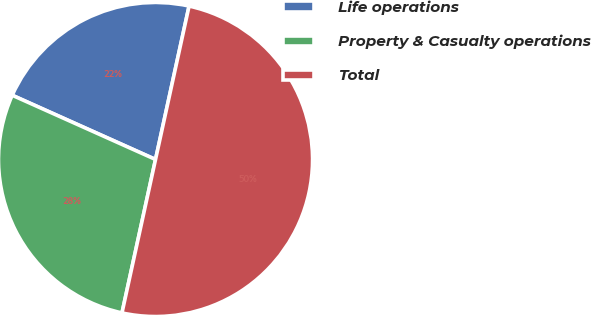<chart> <loc_0><loc_0><loc_500><loc_500><pie_chart><fcel>Life operations<fcel>Property & Casualty operations<fcel>Total<nl><fcel>21.72%<fcel>28.28%<fcel>50.0%<nl></chart> 